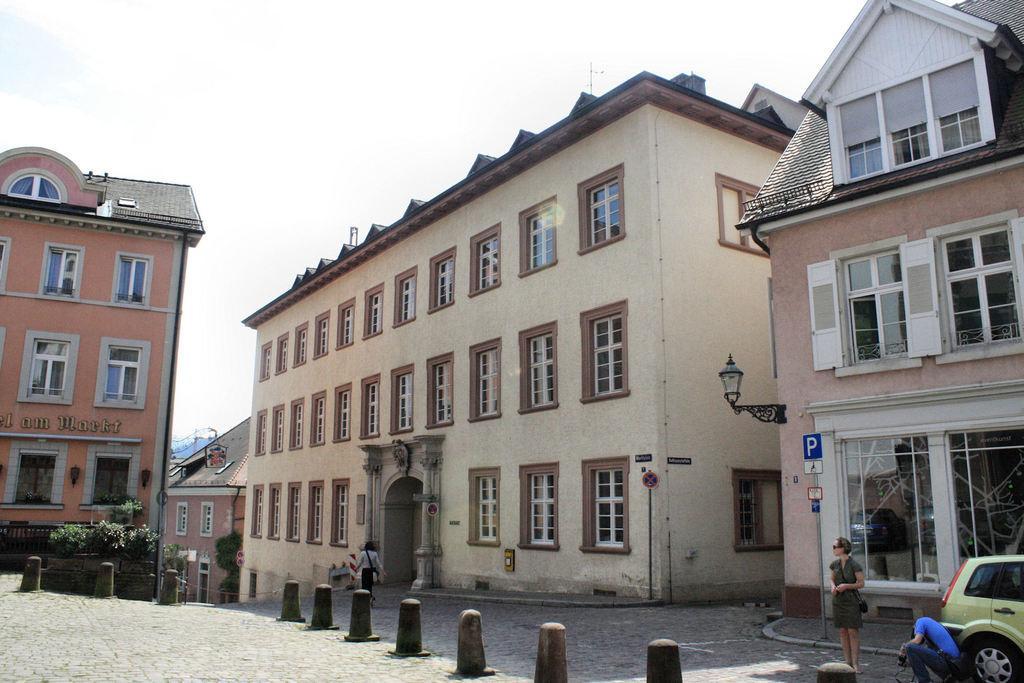Can you describe this image briefly? In this image there is a path, on that path there are two women are standing, in the background there are houses, in the bottom right there is a car and a person near the car, and there are poles and plants. 